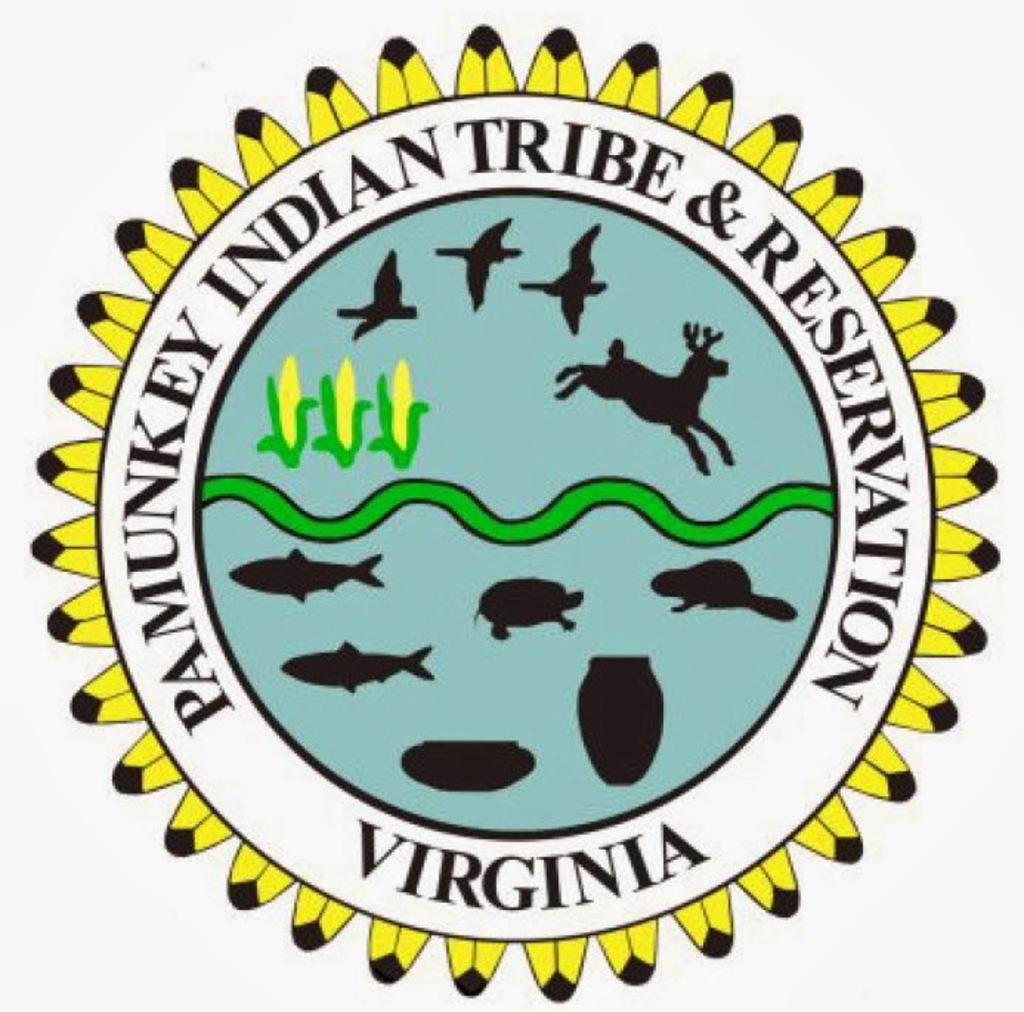What is the main feature of the image? The image contains a logo. What can be found on the logo? There is writing on the logo. What types of drawings are included in the logo? The logo includes drawings of corns, birds, animals, fishes, and pots. How many bells are hanging from the drawings of pots in the image? There are no bells present in the image. 